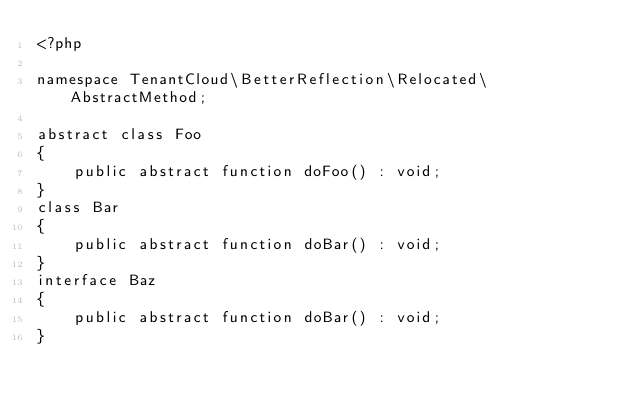<code> <loc_0><loc_0><loc_500><loc_500><_PHP_><?php

namespace TenantCloud\BetterReflection\Relocated\AbstractMethod;

abstract class Foo
{
    public abstract function doFoo() : void;
}
class Bar
{
    public abstract function doBar() : void;
}
interface Baz
{
    public abstract function doBar() : void;
}
</code> 